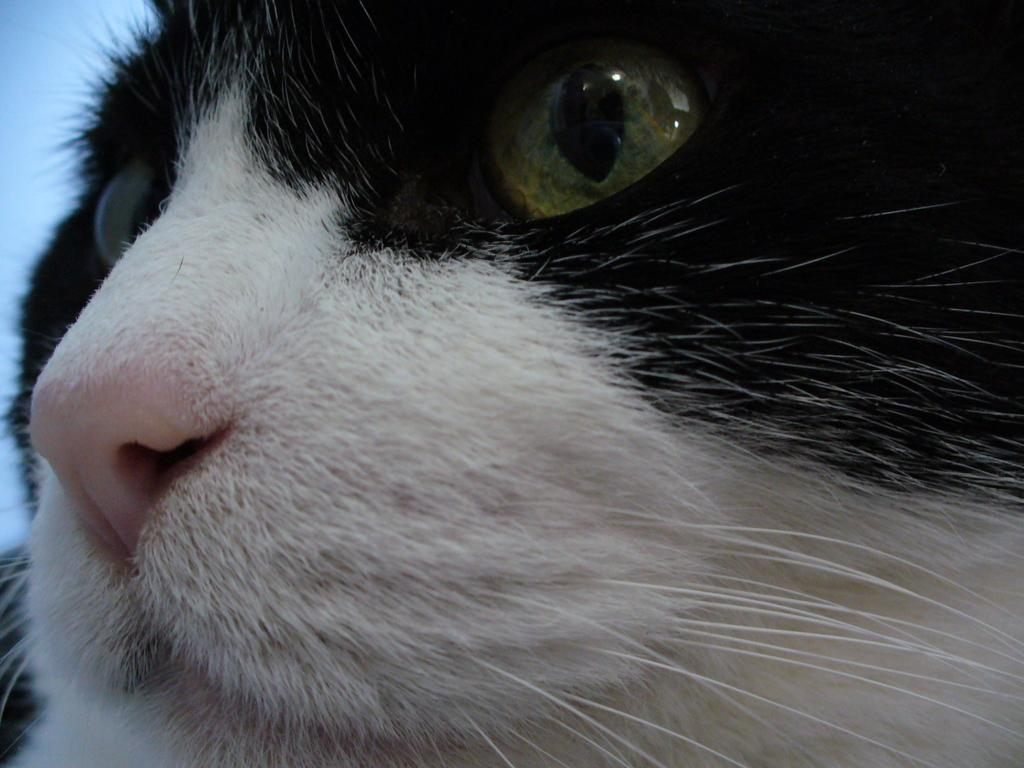What is the main subject of the image? There is a cat face in the image. What color is the background of the image? The background of the image is blue. What type of guitar is being played during the meal in the image? There is no guitar or meal present in the image; it only features a cat face with a blue background. 